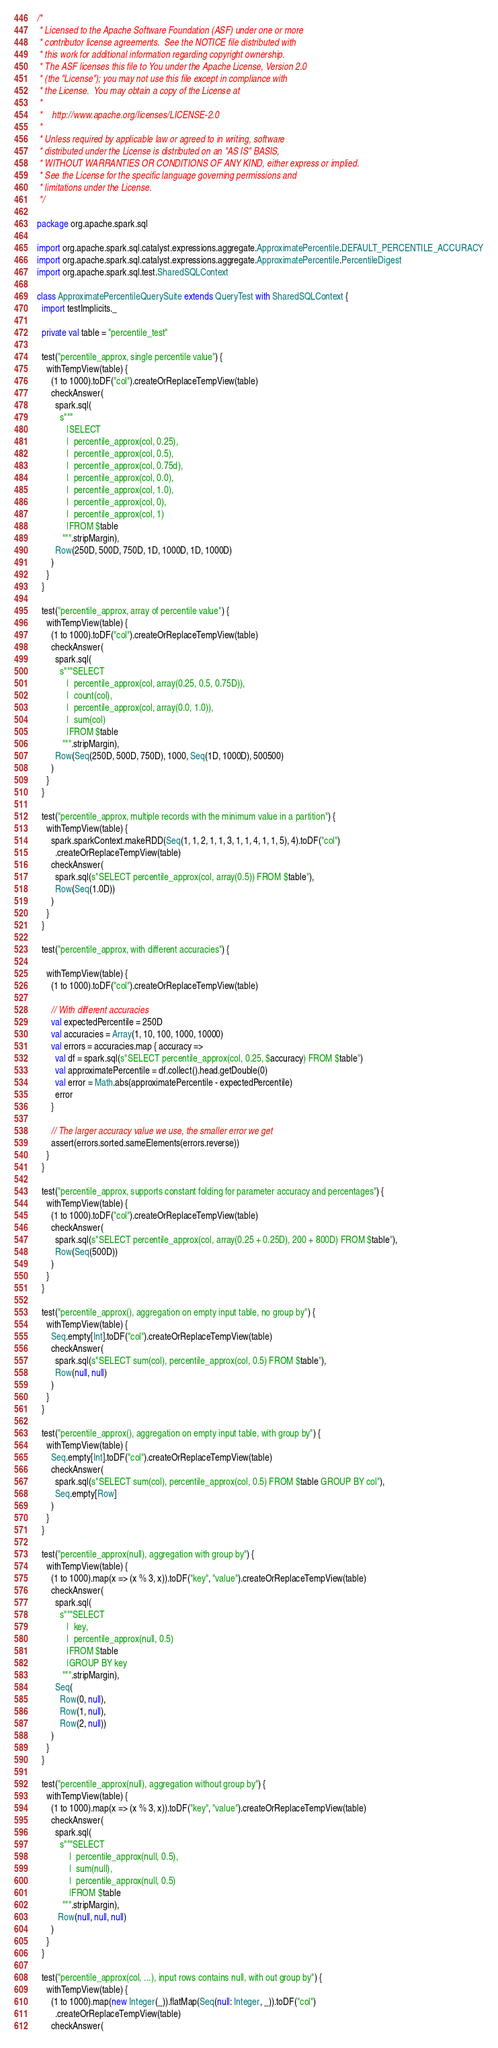Convert code to text. <code><loc_0><loc_0><loc_500><loc_500><_Scala_>/*
 * Licensed to the Apache Software Foundation (ASF) under one or more
 * contributor license agreements.  See the NOTICE file distributed with
 * this work for additional information regarding copyright ownership.
 * The ASF licenses this file to You under the Apache License, Version 2.0
 * (the "License"); you may not use this file except in compliance with
 * the License.  You may obtain a copy of the License at
 *
 *    http://www.apache.org/licenses/LICENSE-2.0
 *
 * Unless required by applicable law or agreed to in writing, software
 * distributed under the License is distributed on an "AS IS" BASIS,
 * WITHOUT WARRANTIES OR CONDITIONS OF ANY KIND, either express or implied.
 * See the License for the specific language governing permissions and
 * limitations under the License.
 */

package org.apache.spark.sql

import org.apache.spark.sql.catalyst.expressions.aggregate.ApproximatePercentile.DEFAULT_PERCENTILE_ACCURACY
import org.apache.spark.sql.catalyst.expressions.aggregate.ApproximatePercentile.PercentileDigest
import org.apache.spark.sql.test.SharedSQLContext

class ApproximatePercentileQuerySuite extends QueryTest with SharedSQLContext {
  import testImplicits._

  private val table = "percentile_test"

  test("percentile_approx, single percentile value") {
    withTempView(table) {
      (1 to 1000).toDF("col").createOrReplaceTempView(table)
      checkAnswer(
        spark.sql(
          s"""
             |SELECT
             |  percentile_approx(col, 0.25),
             |  percentile_approx(col, 0.5),
             |  percentile_approx(col, 0.75d),
             |  percentile_approx(col, 0.0),
             |  percentile_approx(col, 1.0),
             |  percentile_approx(col, 0),
             |  percentile_approx(col, 1)
             |FROM $table
           """.stripMargin),
        Row(250D, 500D, 750D, 1D, 1000D, 1D, 1000D)
      )
    }
  }

  test("percentile_approx, array of percentile value") {
    withTempView(table) {
      (1 to 1000).toDF("col").createOrReplaceTempView(table)
      checkAnswer(
        spark.sql(
          s"""SELECT
             |  percentile_approx(col, array(0.25, 0.5, 0.75D)),
             |  count(col),
             |  percentile_approx(col, array(0.0, 1.0)),
             |  sum(col)
             |FROM $table
           """.stripMargin),
        Row(Seq(250D, 500D, 750D), 1000, Seq(1D, 1000D), 500500)
      )
    }
  }

  test("percentile_approx, multiple records with the minimum value in a partition") {
    withTempView(table) {
      spark.sparkContext.makeRDD(Seq(1, 1, 2, 1, 1, 3, 1, 1, 4, 1, 1, 5), 4).toDF("col")
        .createOrReplaceTempView(table)
      checkAnswer(
        spark.sql(s"SELECT percentile_approx(col, array(0.5)) FROM $table"),
        Row(Seq(1.0D))
      )
    }
  }

  test("percentile_approx, with different accuracies") {

    withTempView(table) {
      (1 to 1000).toDF("col").createOrReplaceTempView(table)

      // With different accuracies
      val expectedPercentile = 250D
      val accuracies = Array(1, 10, 100, 1000, 10000)
      val errors = accuracies.map { accuracy =>
        val df = spark.sql(s"SELECT percentile_approx(col, 0.25, $accuracy) FROM $table")
        val approximatePercentile = df.collect().head.getDouble(0)
        val error = Math.abs(approximatePercentile - expectedPercentile)
        error
      }

      // The larger accuracy value we use, the smaller error we get
      assert(errors.sorted.sameElements(errors.reverse))
    }
  }

  test("percentile_approx, supports constant folding for parameter accuracy and percentages") {
    withTempView(table) {
      (1 to 1000).toDF("col").createOrReplaceTempView(table)
      checkAnswer(
        spark.sql(s"SELECT percentile_approx(col, array(0.25 + 0.25D), 200 + 800D) FROM $table"),
        Row(Seq(500D))
      )
    }
  }

  test("percentile_approx(), aggregation on empty input table, no group by") {
    withTempView(table) {
      Seq.empty[Int].toDF("col").createOrReplaceTempView(table)
      checkAnswer(
        spark.sql(s"SELECT sum(col), percentile_approx(col, 0.5) FROM $table"),
        Row(null, null)
      )
    }
  }

  test("percentile_approx(), aggregation on empty input table, with group by") {
    withTempView(table) {
      Seq.empty[Int].toDF("col").createOrReplaceTempView(table)
      checkAnswer(
        spark.sql(s"SELECT sum(col), percentile_approx(col, 0.5) FROM $table GROUP BY col"),
        Seq.empty[Row]
      )
    }
  }

  test("percentile_approx(null), aggregation with group by") {
    withTempView(table) {
      (1 to 1000).map(x => (x % 3, x)).toDF("key", "value").createOrReplaceTempView(table)
      checkAnswer(
        spark.sql(
          s"""SELECT
             |  key,
             |  percentile_approx(null, 0.5)
             |FROM $table
             |GROUP BY key
           """.stripMargin),
        Seq(
          Row(0, null),
          Row(1, null),
          Row(2, null))
      )
    }
  }

  test("percentile_approx(null), aggregation without group by") {
    withTempView(table) {
      (1 to 1000).map(x => (x % 3, x)).toDF("key", "value").createOrReplaceTempView(table)
      checkAnswer(
        spark.sql(
          s"""SELECT
              |  percentile_approx(null, 0.5),
              |  sum(null),
              |  percentile_approx(null, 0.5)
              |FROM $table
           """.stripMargin),
         Row(null, null, null)
      )
    }
  }

  test("percentile_approx(col, ...), input rows contains null, with out group by") {
    withTempView(table) {
      (1 to 1000).map(new Integer(_)).flatMap(Seq(null: Integer, _)).toDF("col")
        .createOrReplaceTempView(table)
      checkAnswer(</code> 